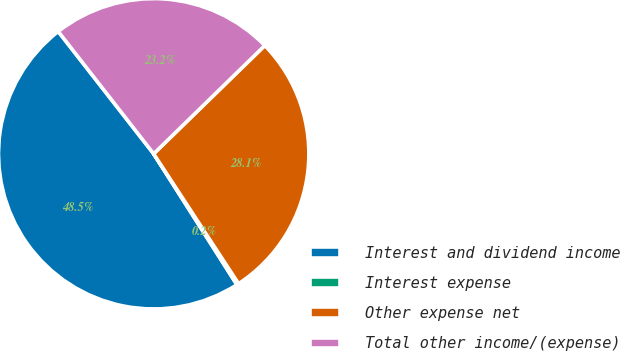Convert chart. <chart><loc_0><loc_0><loc_500><loc_500><pie_chart><fcel>Interest and dividend income<fcel>Interest expense<fcel>Other expense net<fcel>Total other income/(expense)<nl><fcel>48.47%<fcel>0.2%<fcel>28.08%<fcel>23.25%<nl></chart> 